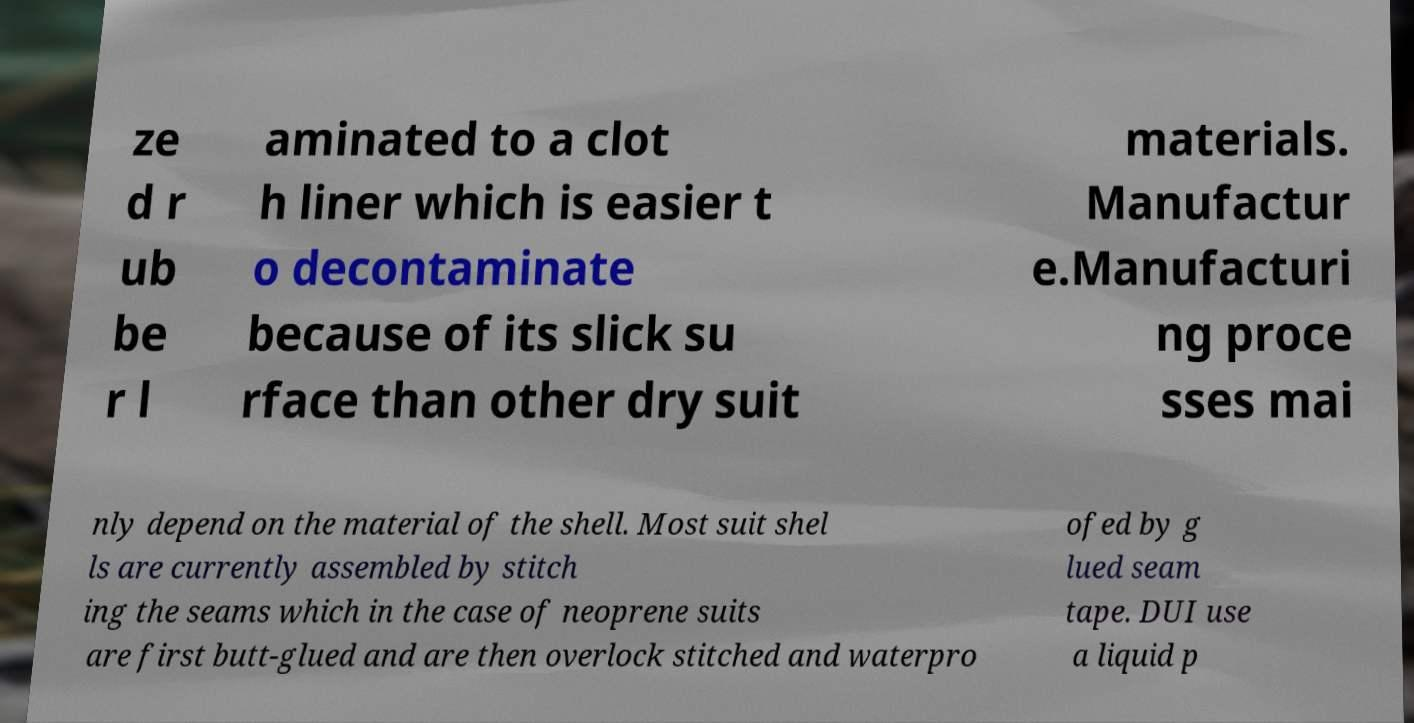There's text embedded in this image that I need extracted. Can you transcribe it verbatim? ze d r ub be r l aminated to a clot h liner which is easier t o decontaminate because of its slick su rface than other dry suit materials. Manufactur e.Manufacturi ng proce sses mai nly depend on the material of the shell. Most suit shel ls are currently assembled by stitch ing the seams which in the case of neoprene suits are first butt-glued and are then overlock stitched and waterpro ofed by g lued seam tape. DUI use a liquid p 